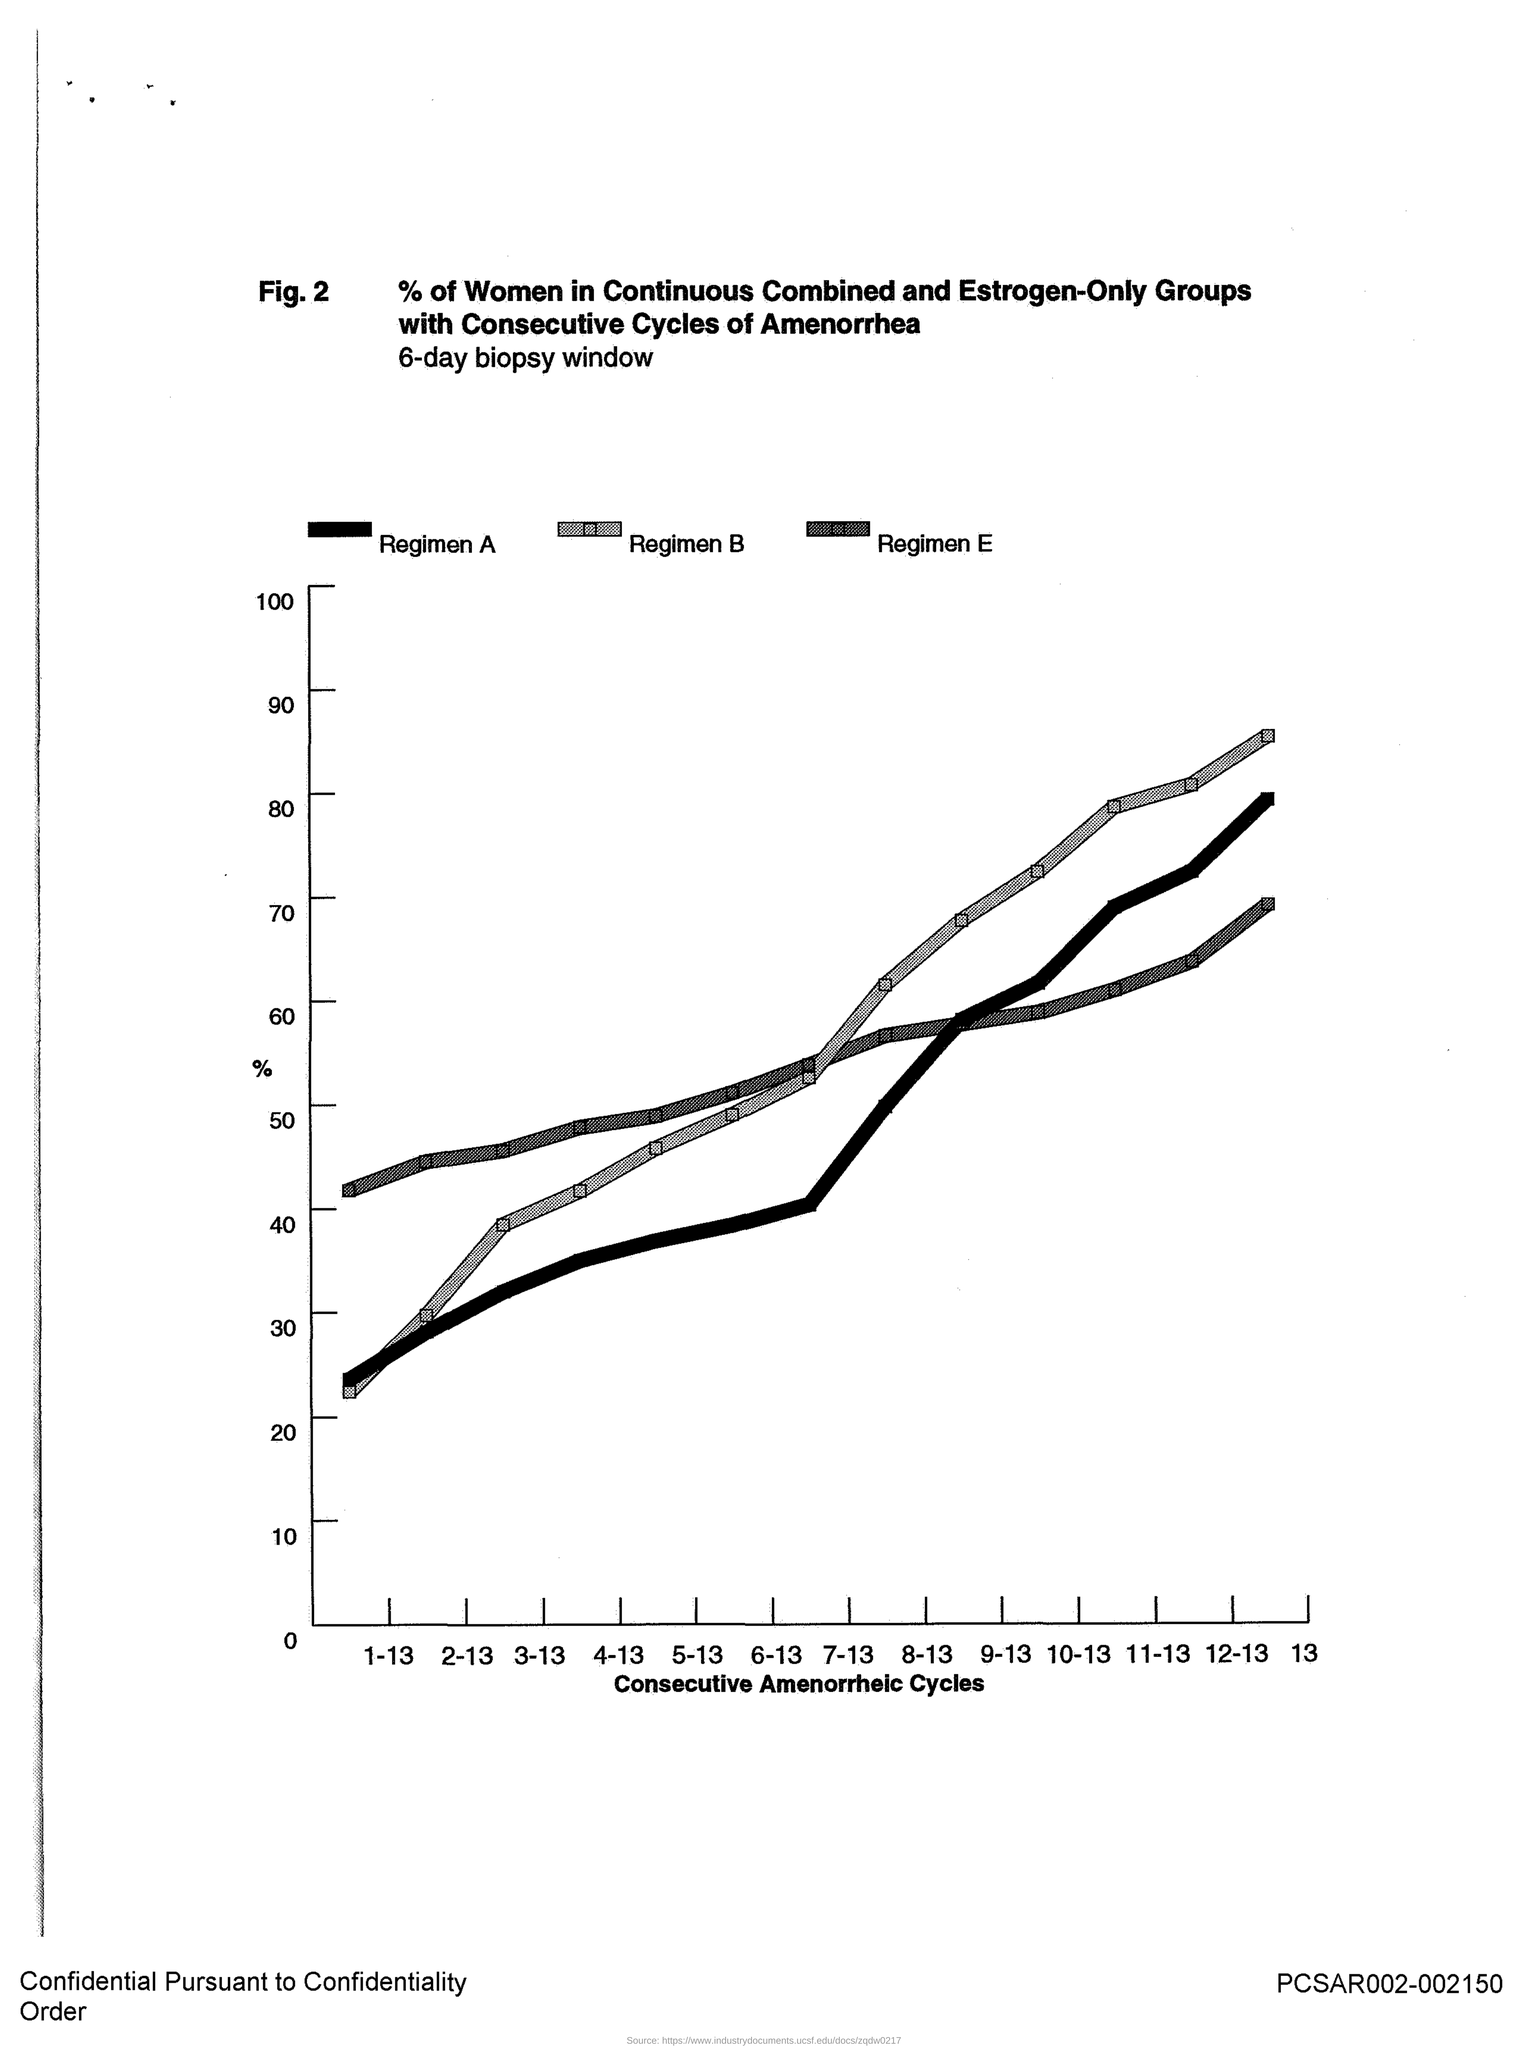What is plotted in the x-axis ?
Ensure brevity in your answer.  Consecutive Amenorrheic Cycles. 